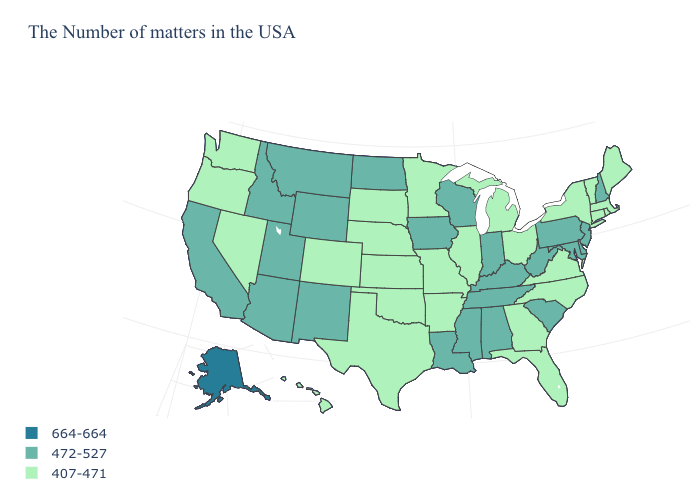Does the first symbol in the legend represent the smallest category?
Keep it brief. No. What is the value of Florida?
Be succinct. 407-471. What is the highest value in the USA?
Write a very short answer. 664-664. What is the lowest value in the West?
Give a very brief answer. 407-471. How many symbols are there in the legend?
Write a very short answer. 3. What is the highest value in the West ?
Give a very brief answer. 664-664. Does Georgia have a lower value than Connecticut?
Quick response, please. No. What is the value of Wyoming?
Concise answer only. 472-527. Is the legend a continuous bar?
Be succinct. No. Does Georgia have the highest value in the South?
Give a very brief answer. No. What is the lowest value in the South?
Write a very short answer. 407-471. What is the lowest value in states that border North Dakota?
Answer briefly. 407-471. Is the legend a continuous bar?
Answer briefly. No. What is the lowest value in the Northeast?
Answer briefly. 407-471. Among the states that border Colorado , which have the lowest value?
Concise answer only. Kansas, Nebraska, Oklahoma. 